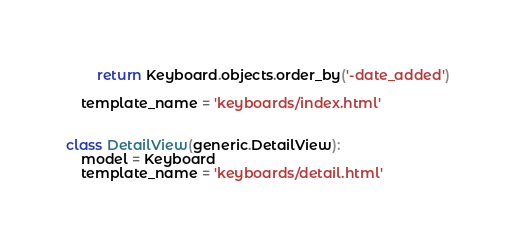<code> <loc_0><loc_0><loc_500><loc_500><_Python_>		return Keyboard.objects.order_by('-date_added')

	template_name = 'keyboards/index.html'


class DetailView(generic.DetailView):
	model = Keyboard
	template_name = 'keyboards/detail.html'
</code> 